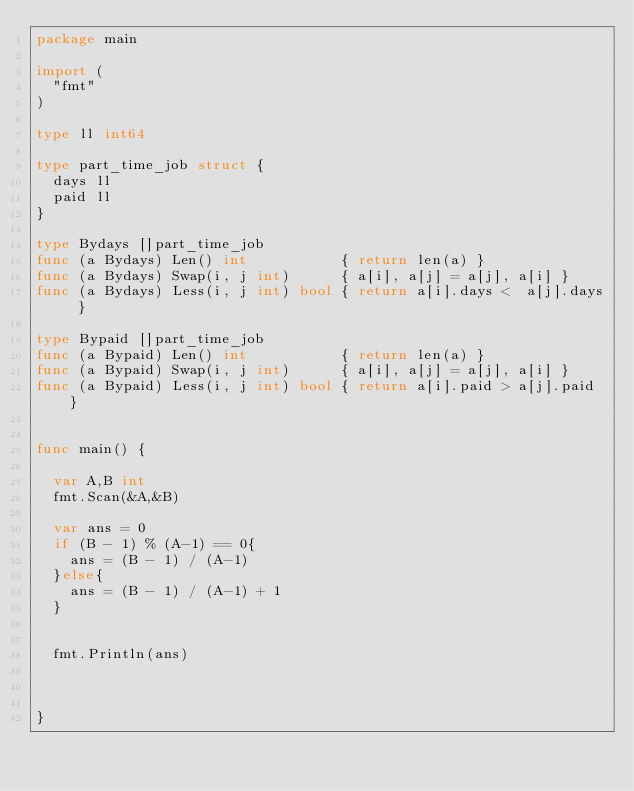Convert code to text. <code><loc_0><loc_0><loc_500><loc_500><_Go_>package main

import (
	"fmt"
)

type ll int64

type part_time_job struct {
	days ll
	paid ll
}

type Bydays []part_time_job
func (a Bydays) Len() int           { return len(a) }
func (a Bydays) Swap(i, j int)      { a[i], a[j] = a[j], a[i] }
func (a Bydays) Less(i, j int) bool { return a[i].days <  a[j].days }

type Bypaid []part_time_job
func (a Bypaid) Len() int           { return len(a) }
func (a Bypaid) Swap(i, j int)      { a[i], a[j] = a[j], a[i] }
func (a Bypaid) Less(i, j int) bool { return a[i].paid > a[j].paid }


func main() {

	var A,B int
	fmt.Scan(&A,&B)

	var ans = 0
	if (B - 1) % (A-1) == 0{
		ans = (B - 1) / (A-1)
	}else{
		ans = (B - 1) / (A-1) + 1
	}


	fmt.Println(ans)



}
</code> 